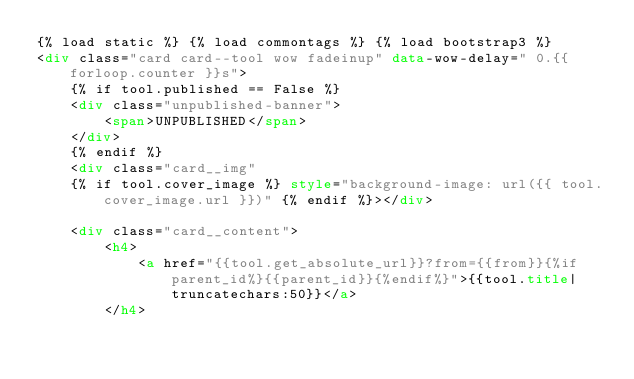Convert code to text. <code><loc_0><loc_0><loc_500><loc_500><_HTML_>{% load static %} {% load commontags %} {% load bootstrap3 %}
<div class="card card--tool wow fadeinup" data-wow-delay=" 0.{{ forloop.counter }}s">
    {% if tool.published == False %}
    <div class="unpublished-banner">
        <span>UNPUBLISHED</span>
    </div>
    {% endif %}
    <div class="card__img" 
    {% if tool.cover_image %} style="background-image: url({{ tool.cover_image.url }})" {% endif %}></div>
   
    <div class="card__content">
        <h4>
            <a href="{{tool.get_absolute_url}}?from={{from}}{%if parent_id%}{{parent_id}}{%endif%}">{{tool.title|truncatechars:50}}</a>
        </h4></code> 